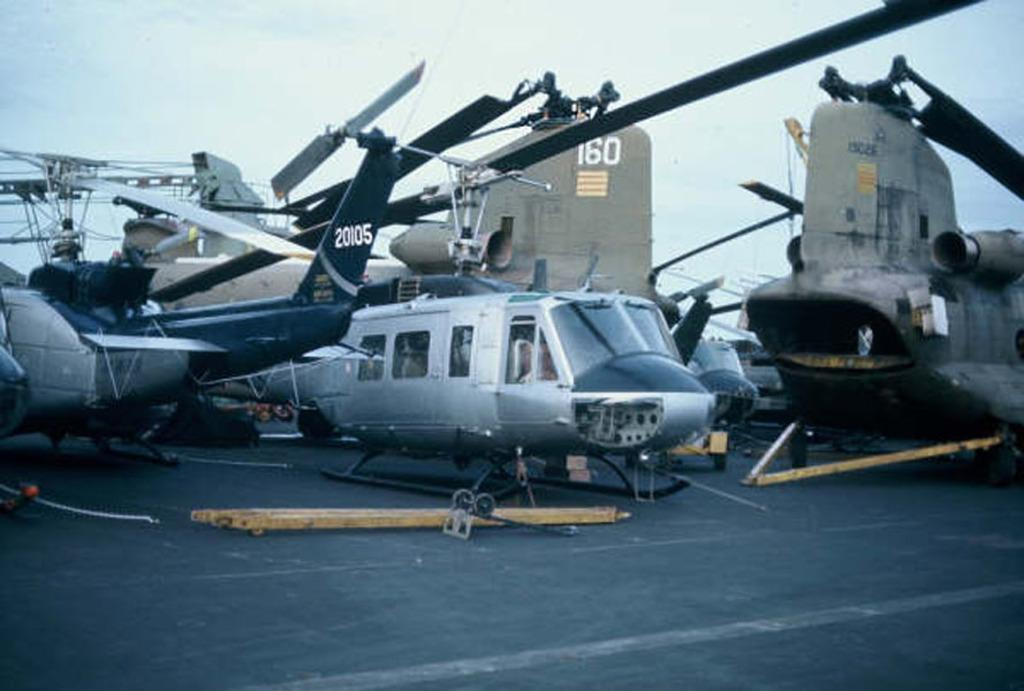Provide a one-sentence caption for the provided image. A helicopter on the tarmac has the number 20105 on its tail. 